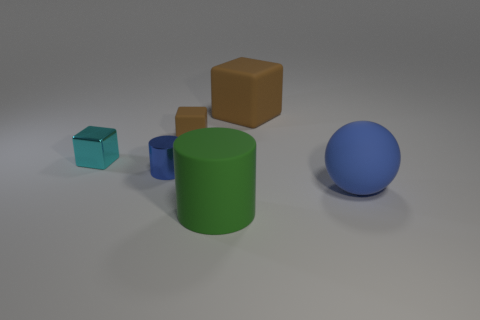Add 2 cubes. How many objects exist? 8 Subtract all spheres. How many objects are left? 5 Subtract 0 cyan cylinders. How many objects are left? 6 Subtract all large rubber blocks. Subtract all blue rubber spheres. How many objects are left? 4 Add 6 cyan things. How many cyan things are left? 7 Add 6 small purple rubber balls. How many small purple rubber balls exist? 6 